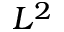<formula> <loc_0><loc_0><loc_500><loc_500>L ^ { 2 }</formula> 